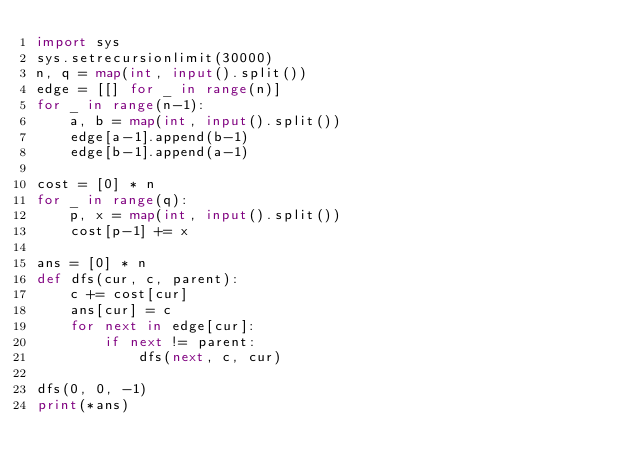Convert code to text. <code><loc_0><loc_0><loc_500><loc_500><_Python_>import sys
sys.setrecursionlimit(30000)
n, q = map(int, input().split())
edge = [[] for _ in range(n)]
for _ in range(n-1):
    a, b = map(int, input().split())
    edge[a-1].append(b-1)
    edge[b-1].append(a-1)

cost = [0] * n
for _ in range(q):
    p, x = map(int, input().split())
    cost[p-1] += x

ans = [0] * n
def dfs(cur, c, parent):
    c += cost[cur]
    ans[cur] = c
    for next in edge[cur]:
        if next != parent:
            dfs(next, c, cur)

dfs(0, 0, -1)
print(*ans)</code> 